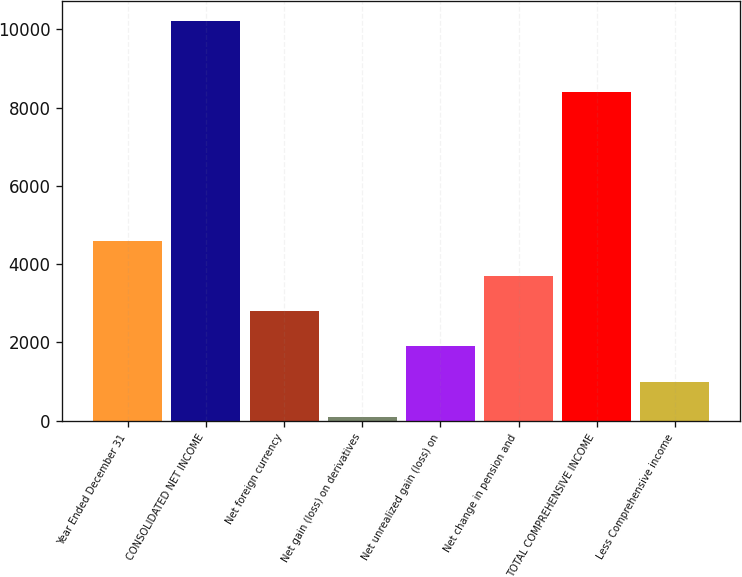<chart> <loc_0><loc_0><loc_500><loc_500><bar_chart><fcel>Year Ended December 31<fcel>CONSOLIDATED NET INCOME<fcel>Net foreign currency<fcel>Net gain (loss) on derivatives<fcel>Net unrealized gain (loss) on<fcel>Net change in pension and<fcel>TOTAL COMPREHENSIVE INCOME<fcel>Less Comprehensive income<nl><fcel>4592.5<fcel>10205.4<fcel>2795.1<fcel>99<fcel>1896.4<fcel>3693.8<fcel>8408<fcel>997.7<nl></chart> 